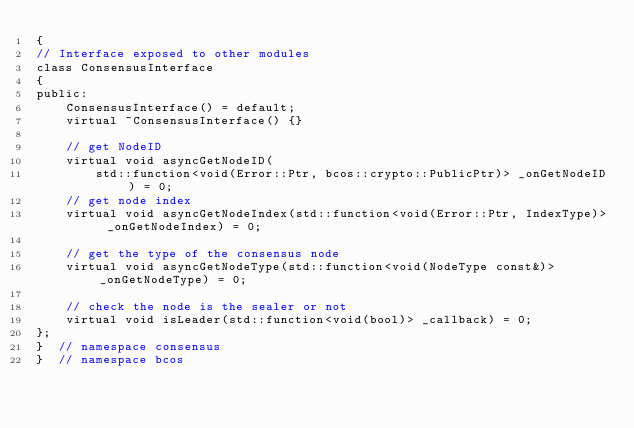Convert code to text. <code><loc_0><loc_0><loc_500><loc_500><_C_>{
// Interface exposed to other modules
class ConsensusInterface
{
public:
    ConsensusInterface() = default;
    virtual ~ConsensusInterface() {}

    // get NodeID
    virtual void asyncGetNodeID(
        std::function<void(Error::Ptr, bcos::crypto::PublicPtr)> _onGetNodeID) = 0;
    // get node index
    virtual void asyncGetNodeIndex(std::function<void(Error::Ptr, IndexType)> _onGetNodeIndex) = 0;

    // get the type of the consensus node
    virtual void asyncGetNodeType(std::function<void(NodeType const&)> _onGetNodeType) = 0;

    // check the node is the sealer or not
    virtual void isLeader(std::function<void(bool)> _callback) = 0;
};
}  // namespace consensus
}  // namespace bcos
</code> 